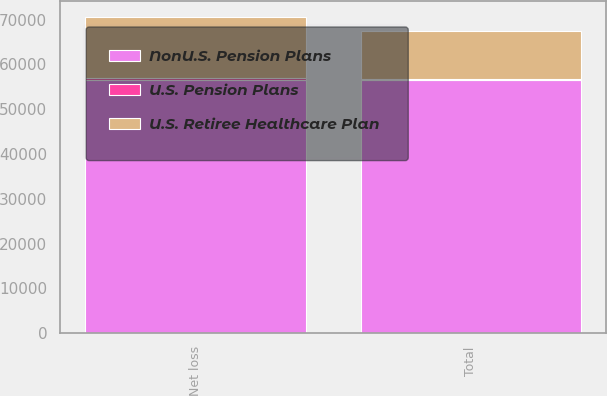Convert chart to OTSL. <chart><loc_0><loc_0><loc_500><loc_500><stacked_bar_chart><ecel><fcel>Net loss<fcel>Total<nl><fcel>NonU.S. Pension Plans<fcel>56479<fcel>56479<nl><fcel>U.S. Pension Plans<fcel>395<fcel>290<nl><fcel>U.S. Retiree Healthcare Plan<fcel>13674<fcel>10736<nl></chart> 